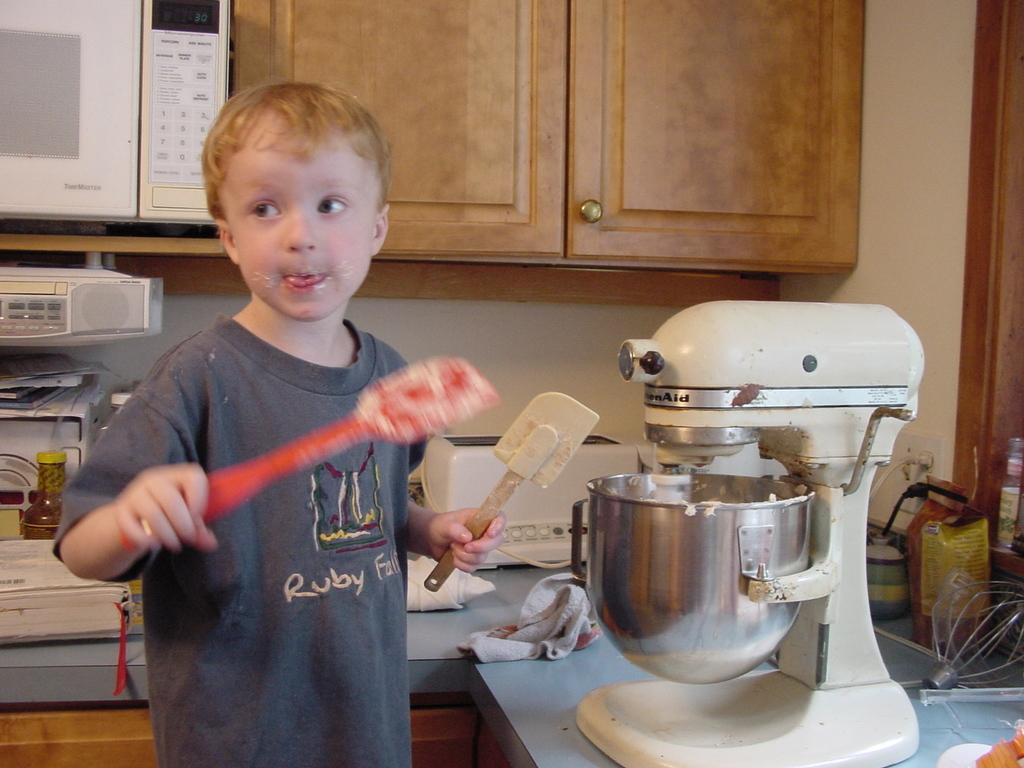What brand is the mixer?
Your response must be concise. Kitchenaid. What is the name of the waterfall on the boy's shirt?
Provide a short and direct response. Ruby falls. 